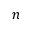Convert formula to latex. <formula><loc_0><loc_0><loc_500><loc_500>n</formula> 